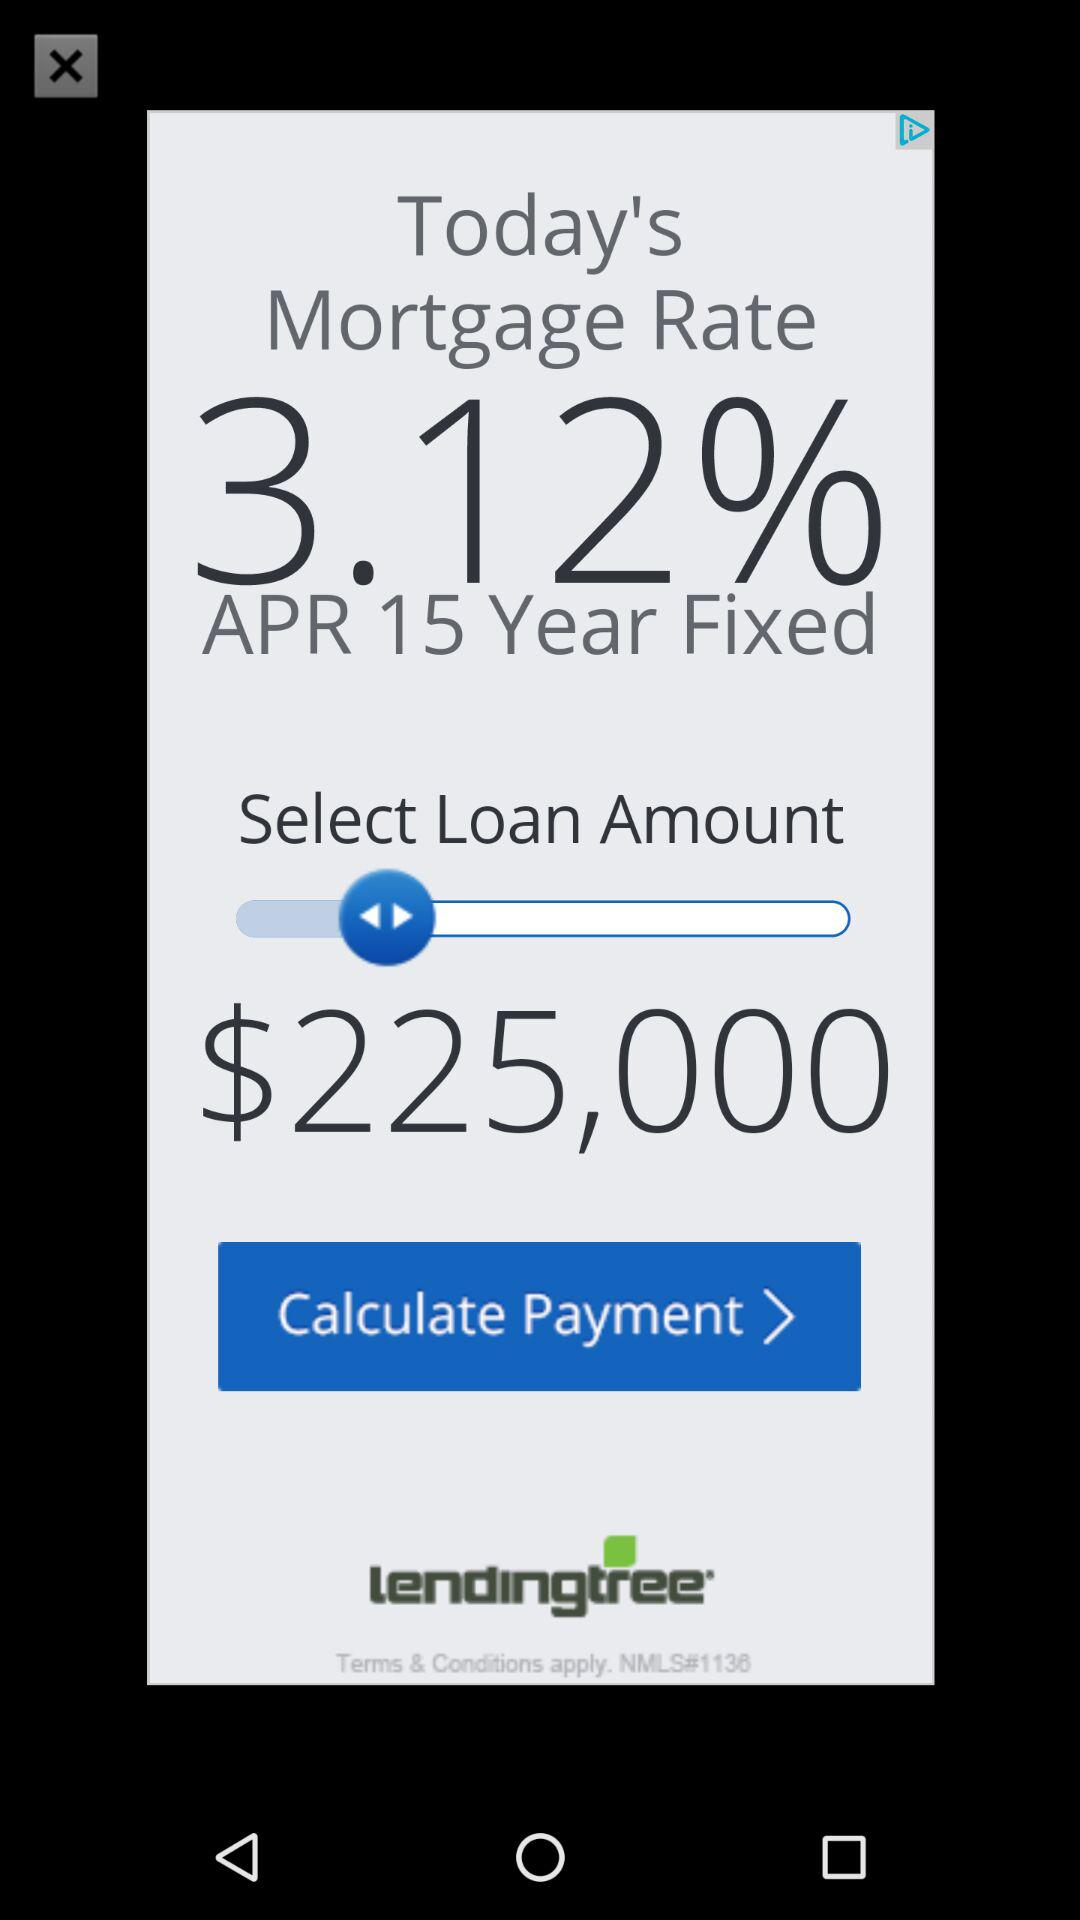What is the selected loan amount? The selected loan amount is $225,000. 